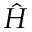Convert formula to latex. <formula><loc_0><loc_0><loc_500><loc_500>\hat { H }</formula> 